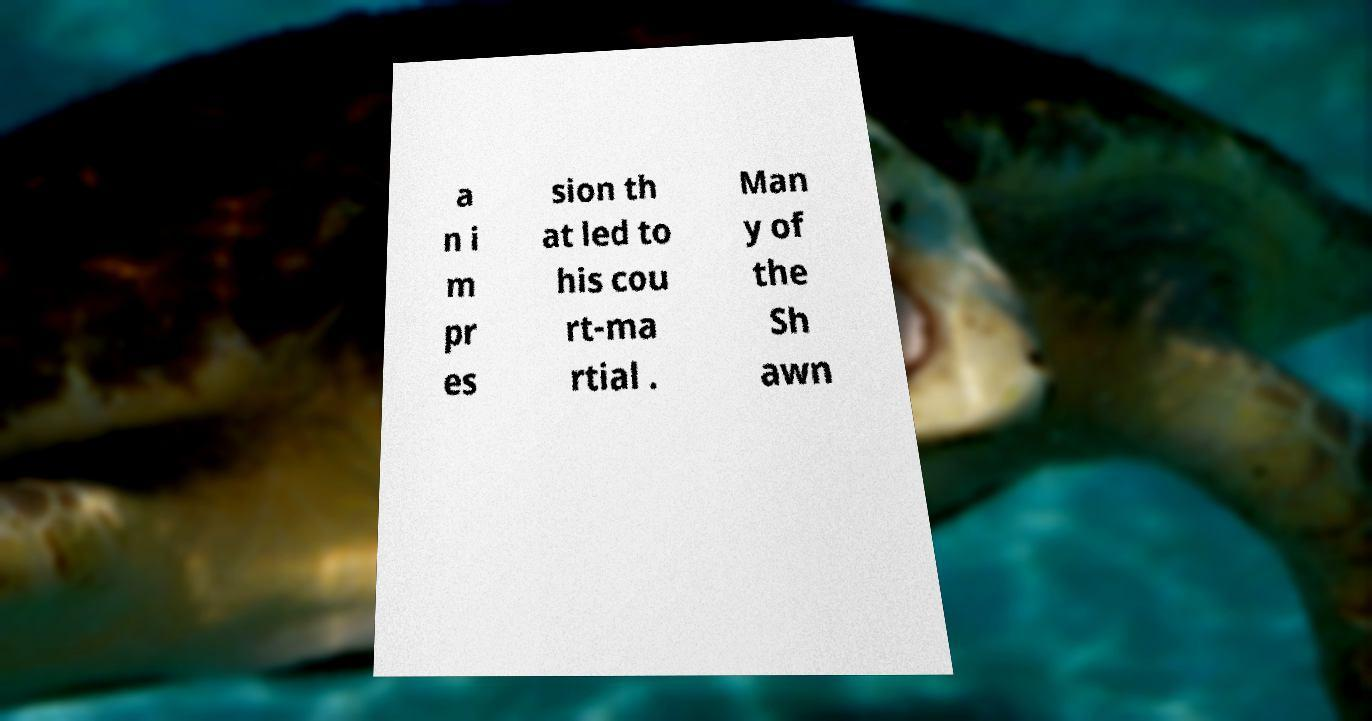What messages or text are displayed in this image? I need them in a readable, typed format. a n i m pr es sion th at led to his cou rt-ma rtial . Man y of the Sh awn 